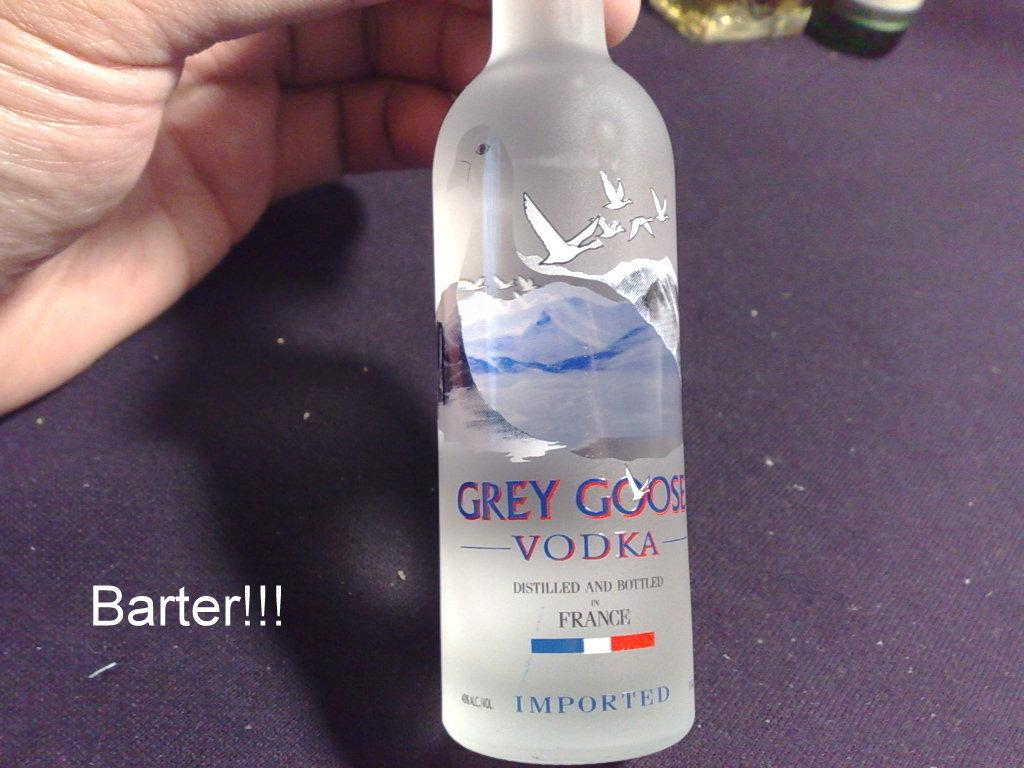What is the person holding in the image? The person is holding a camera. What can be seen in the background of the image? There is a building in the background of the image. Is there any furniture visible in the image? No, there is no furniture visible in the image. What is the hour hand pointing to on the table in the image? There is no clock or hour hand present in the image. How many cents are visible on the table in the image? There are no coins or currency visible on the table in the image. 